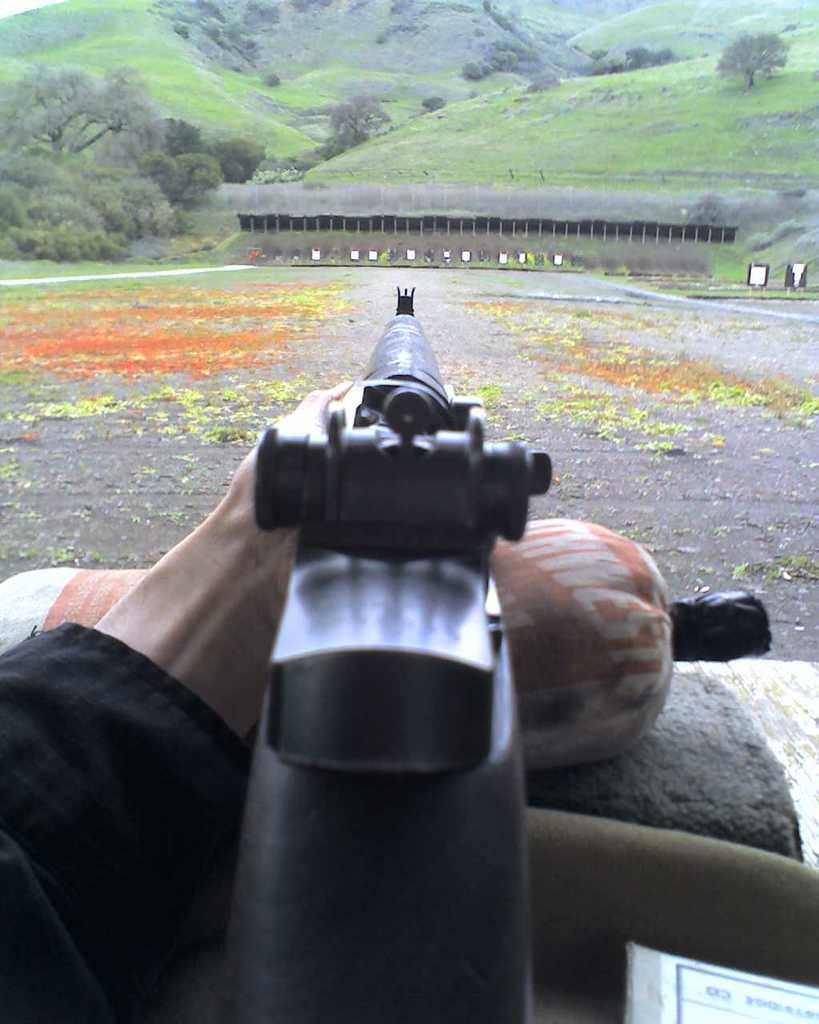What object is the main subject of the image? There is a gun in the image. How is the gun positioned in the image? The gun is placed on a cylindrical pillow. What can be seen in the background of the image? There are trees and hills in the background of the image. What type of snake can be seen wrapped around the gun in the image? There is no snake present in the image; it only features a gun placed on a cylindrical pillow with trees and hills in the background. 